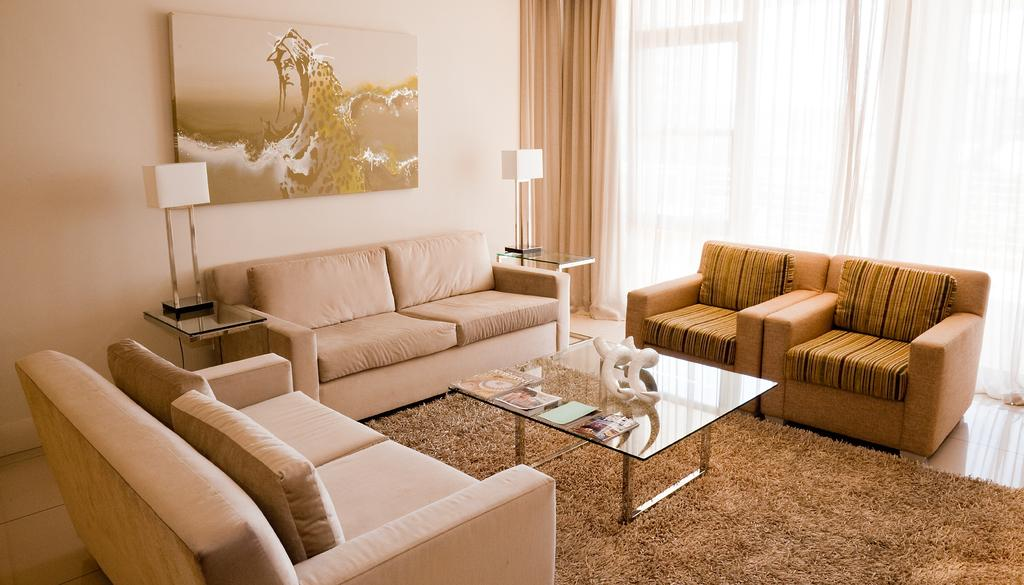What type of space is depicted in the image? There is a room in the image. What furniture is present in the room? There is a sofa and a table in the room. What is on the table in the image? There is a poster and paper on the table. What can be seen in the background of the room? There is a wall, a curtain, a lamp, and a floor mat visible in the background. What type of flag is the kitty playing with in the room? There is no kitty or flag present in the image, so it is not possible to answer that question. 